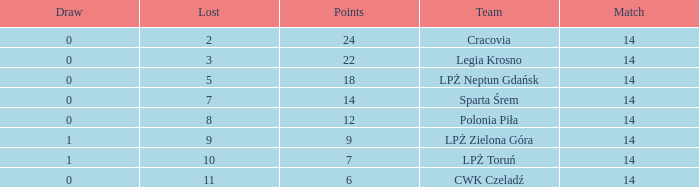What is the sum for the match with a draw less than 0? None. 